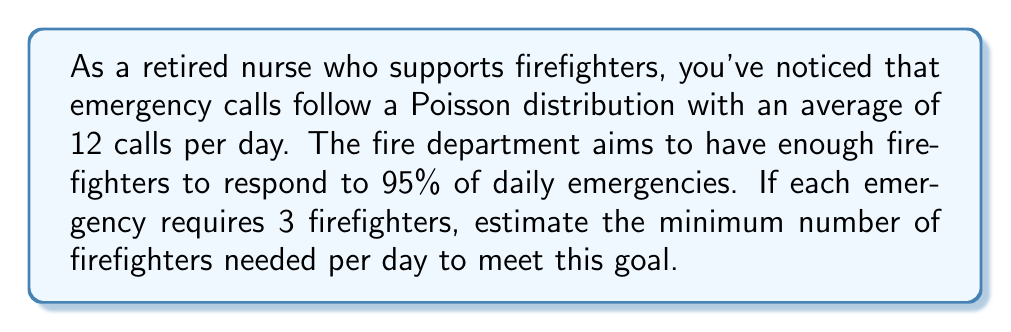What is the answer to this math problem? 1. The Poisson distribution models the number of events in a fixed interval. Here, $\lambda = 12$ calls per day.

2. To find the number of calls that covers 95% of cases, we need to find $x$ such that $P(X \leq x) \approx 0.95$, where $X$ is the random variable representing the number of calls.

3. Using the cumulative distribution function of the Poisson distribution:
   
   $P(X \leq x) = e^{-\lambda} \sum_{k=0}^x \frac{\lambda^k}{k!}$

4. We can use software or tables to find that $x = 18$ satisfies this condition, as $P(X \leq 18) \approx 0.9578$.

5. Now that we know we need to prepare for up to 18 calls per day, we can calculate the number of firefighters:

   $\text{Firefighters needed} = 18 \text{ calls} \times 3 \text{ firefighters per call} = 54 \text{ firefighters}$

6. Therefore, the fire department needs a minimum of 54 firefighters per day to respond to 95% of daily emergencies.
Answer: 54 firefighters 